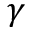Convert formula to latex. <formula><loc_0><loc_0><loc_500><loc_500>\gamma</formula> 